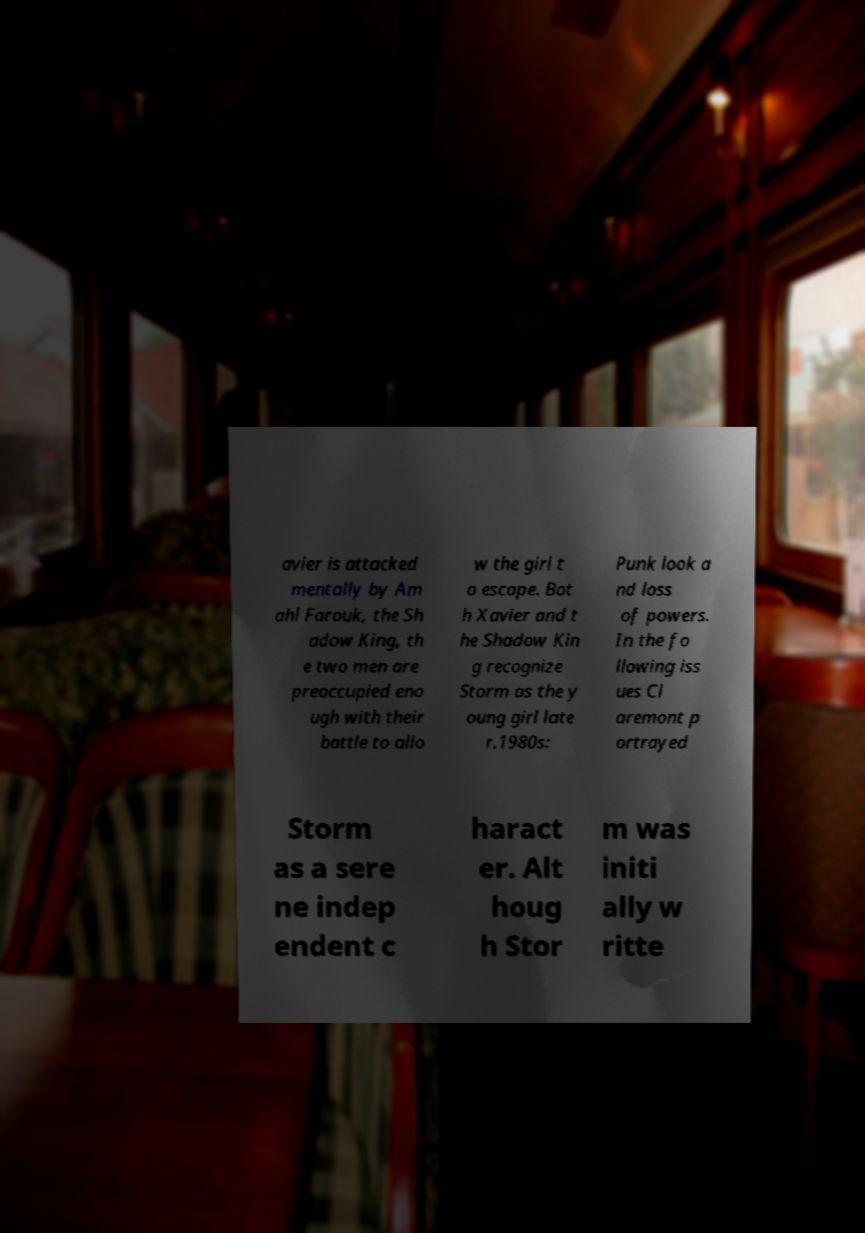I need the written content from this picture converted into text. Can you do that? avier is attacked mentally by Am ahl Farouk, the Sh adow King, th e two men are preoccupied eno ugh with their battle to allo w the girl t o escape. Bot h Xavier and t he Shadow Kin g recognize Storm as the y oung girl late r.1980s: Punk look a nd loss of powers. In the fo llowing iss ues Cl aremont p ortrayed Storm as a sere ne indep endent c haract er. Alt houg h Stor m was initi ally w ritte 